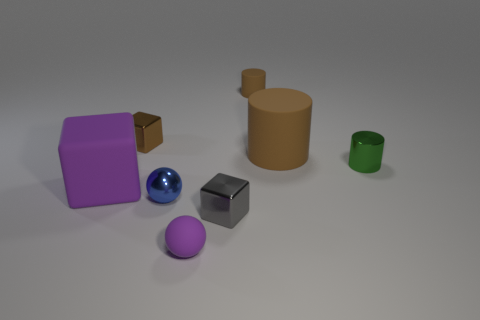Add 1 small blue things. How many objects exist? 9 Subtract all cylinders. How many objects are left? 5 Subtract 0 brown spheres. How many objects are left? 8 Subtract all tiny brown things. Subtract all tiny green things. How many objects are left? 5 Add 6 small green cylinders. How many small green cylinders are left? 7 Add 8 tiny brown things. How many tiny brown things exist? 10 